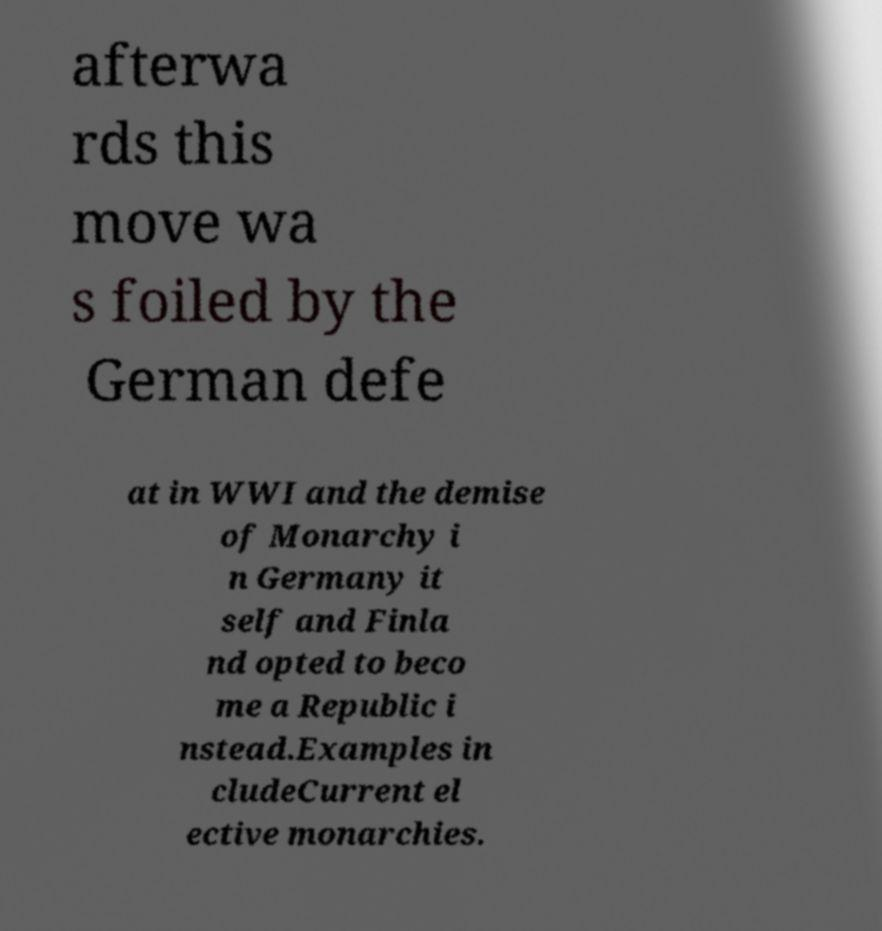Can you read and provide the text displayed in the image?This photo seems to have some interesting text. Can you extract and type it out for me? afterwa rds this move wa s foiled by the German defe at in WWI and the demise of Monarchy i n Germany it self and Finla nd opted to beco me a Republic i nstead.Examples in cludeCurrent el ective monarchies. 